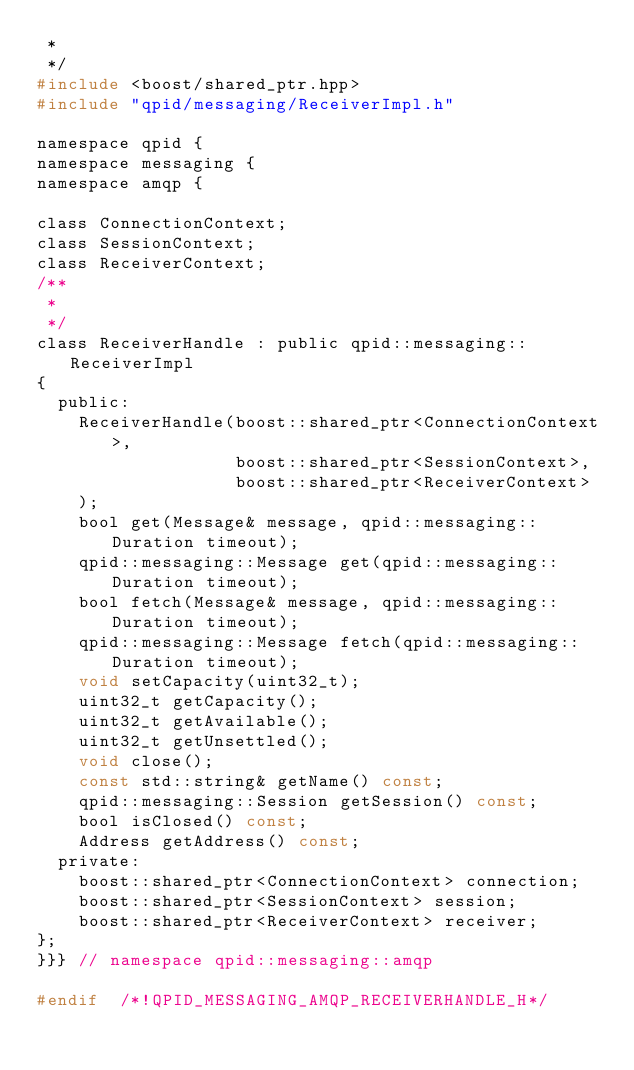Convert code to text. <code><loc_0><loc_0><loc_500><loc_500><_C_> *
 */
#include <boost/shared_ptr.hpp>
#include "qpid/messaging/ReceiverImpl.h"

namespace qpid {
namespace messaging {
namespace amqp {

class ConnectionContext;
class SessionContext;
class ReceiverContext;
/**
 *
 */
class ReceiverHandle : public qpid::messaging::ReceiverImpl
{
  public:
    ReceiverHandle(boost::shared_ptr<ConnectionContext>,
                   boost::shared_ptr<SessionContext>,
                   boost::shared_ptr<ReceiverContext>
    );
    bool get(Message& message, qpid::messaging::Duration timeout);
    qpid::messaging::Message get(qpid::messaging::Duration timeout);
    bool fetch(Message& message, qpid::messaging::Duration timeout);
    qpid::messaging::Message fetch(qpid::messaging::Duration timeout);
    void setCapacity(uint32_t);
    uint32_t getCapacity();
    uint32_t getAvailable();
    uint32_t getUnsettled();
    void close();
    const std::string& getName() const;
    qpid::messaging::Session getSession() const;
    bool isClosed() const;
    Address getAddress() const;
  private:
    boost::shared_ptr<ConnectionContext> connection;
    boost::shared_ptr<SessionContext> session;
    boost::shared_ptr<ReceiverContext> receiver;
};
}}} // namespace qpid::messaging::amqp

#endif  /*!QPID_MESSAGING_AMQP_RECEIVERHANDLE_H*/
</code> 